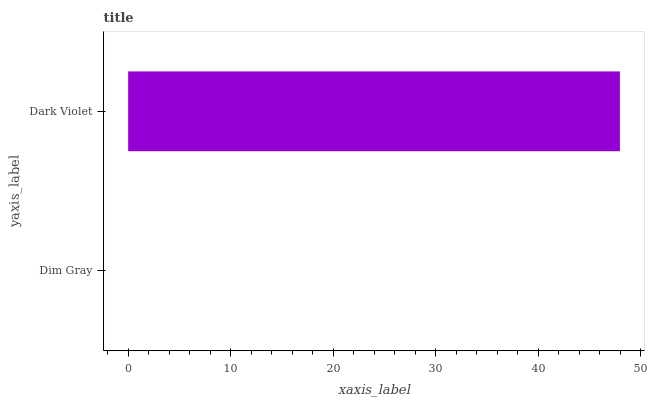Is Dim Gray the minimum?
Answer yes or no. Yes. Is Dark Violet the maximum?
Answer yes or no. Yes. Is Dark Violet the minimum?
Answer yes or no. No. Is Dark Violet greater than Dim Gray?
Answer yes or no. Yes. Is Dim Gray less than Dark Violet?
Answer yes or no. Yes. Is Dim Gray greater than Dark Violet?
Answer yes or no. No. Is Dark Violet less than Dim Gray?
Answer yes or no. No. Is Dark Violet the high median?
Answer yes or no. Yes. Is Dim Gray the low median?
Answer yes or no. Yes. Is Dim Gray the high median?
Answer yes or no. No. Is Dark Violet the low median?
Answer yes or no. No. 